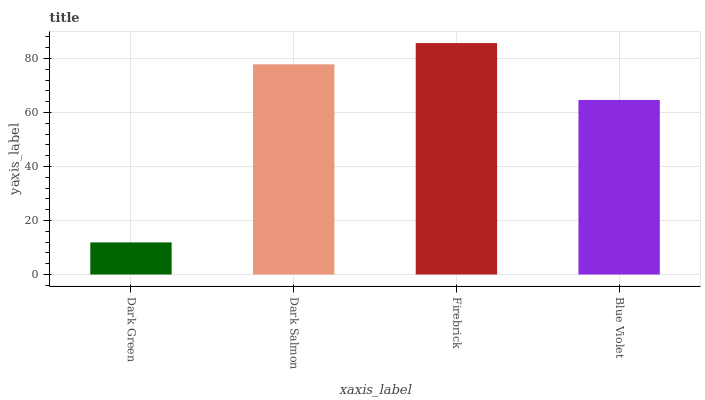Is Dark Green the minimum?
Answer yes or no. Yes. Is Firebrick the maximum?
Answer yes or no. Yes. Is Dark Salmon the minimum?
Answer yes or no. No. Is Dark Salmon the maximum?
Answer yes or no. No. Is Dark Salmon greater than Dark Green?
Answer yes or no. Yes. Is Dark Green less than Dark Salmon?
Answer yes or no. Yes. Is Dark Green greater than Dark Salmon?
Answer yes or no. No. Is Dark Salmon less than Dark Green?
Answer yes or no. No. Is Dark Salmon the high median?
Answer yes or no. Yes. Is Blue Violet the low median?
Answer yes or no. Yes. Is Dark Green the high median?
Answer yes or no. No. Is Dark Salmon the low median?
Answer yes or no. No. 